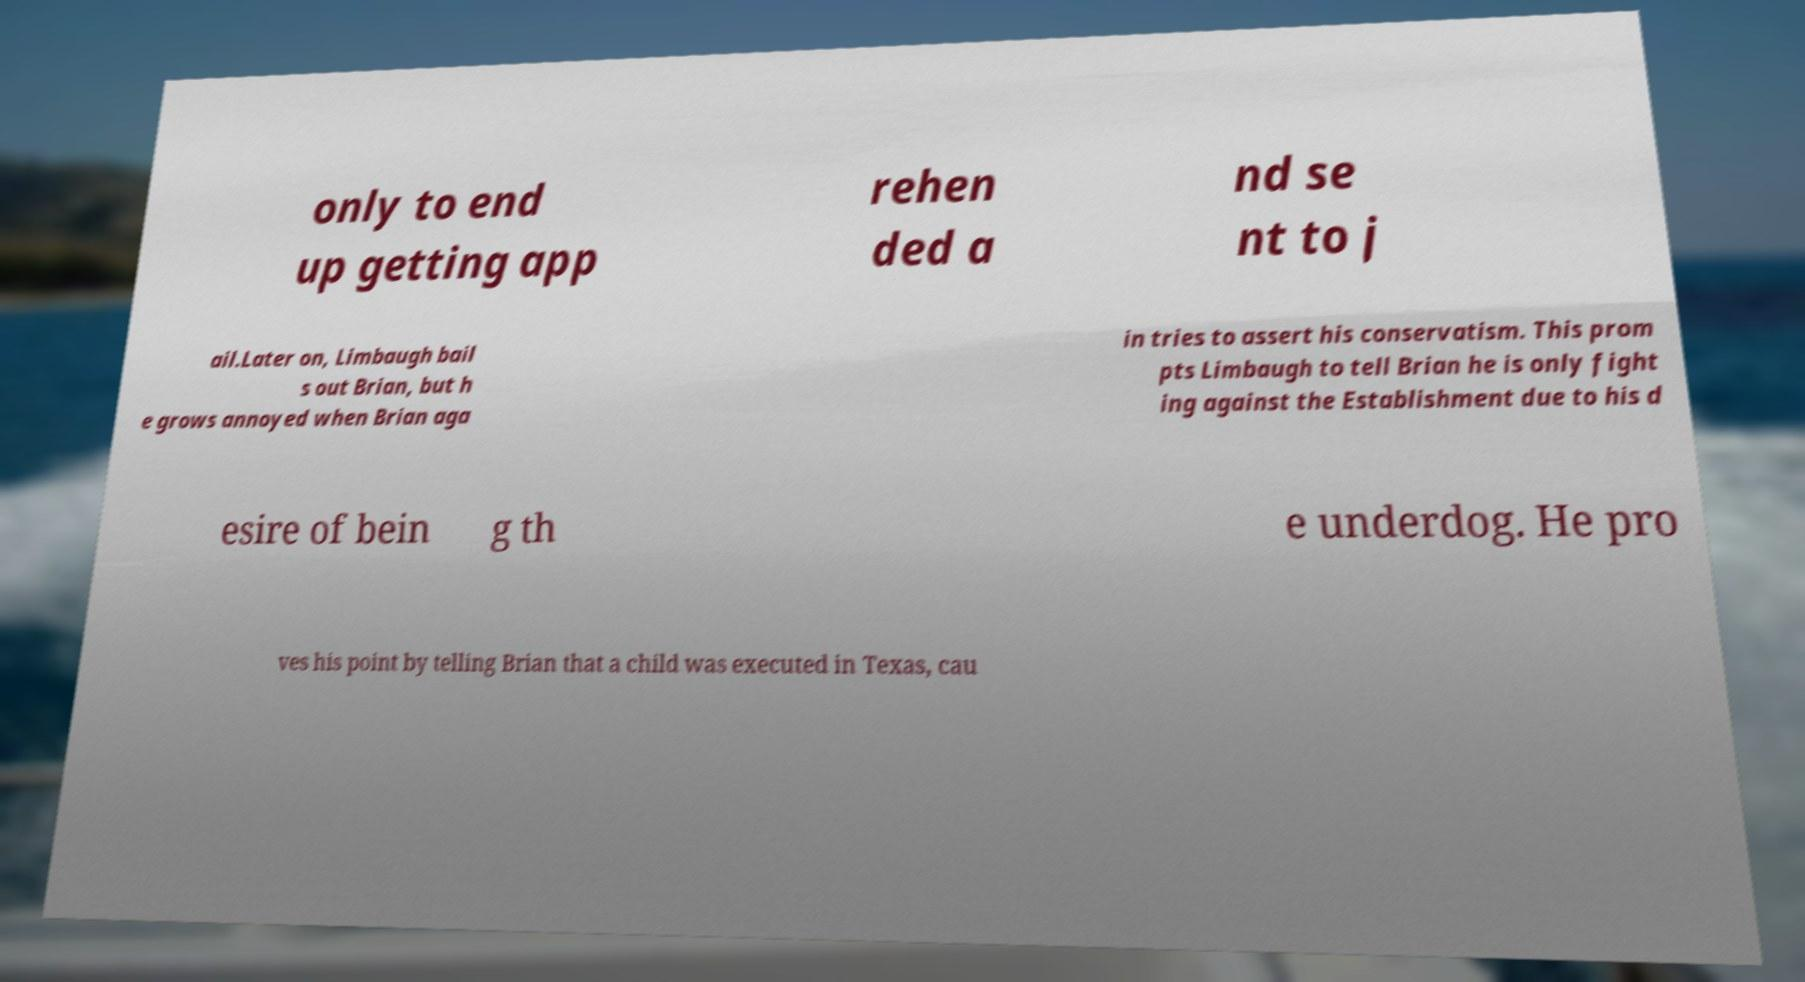There's text embedded in this image that I need extracted. Can you transcribe it verbatim? only to end up getting app rehen ded a nd se nt to j ail.Later on, Limbaugh bail s out Brian, but h e grows annoyed when Brian aga in tries to assert his conservatism. This prom pts Limbaugh to tell Brian he is only fight ing against the Establishment due to his d esire of bein g th e underdog. He pro ves his point by telling Brian that a child was executed in Texas, cau 